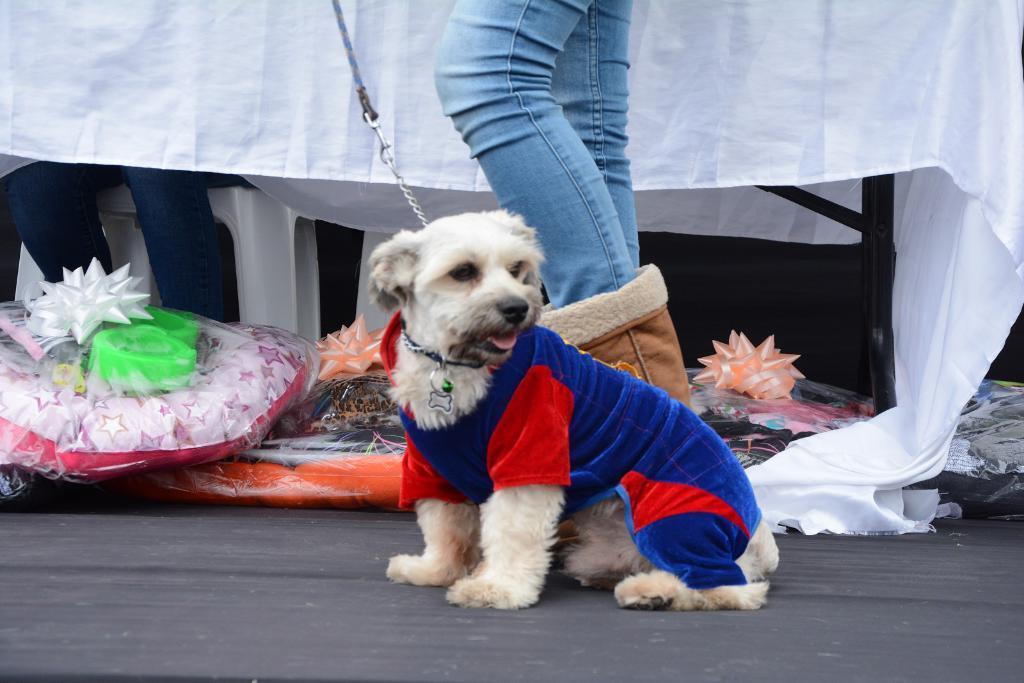Could you give a brief overview of what you see in this image? In this image, we can see a dog is sitting on the surface. Background we can see few objects and things. Here a person is standing behind the dog. Top of the image, we can see white cloth. On the left side of the image, we can see a person is sitting on the white chair. Right side of the image, we can see rods. 